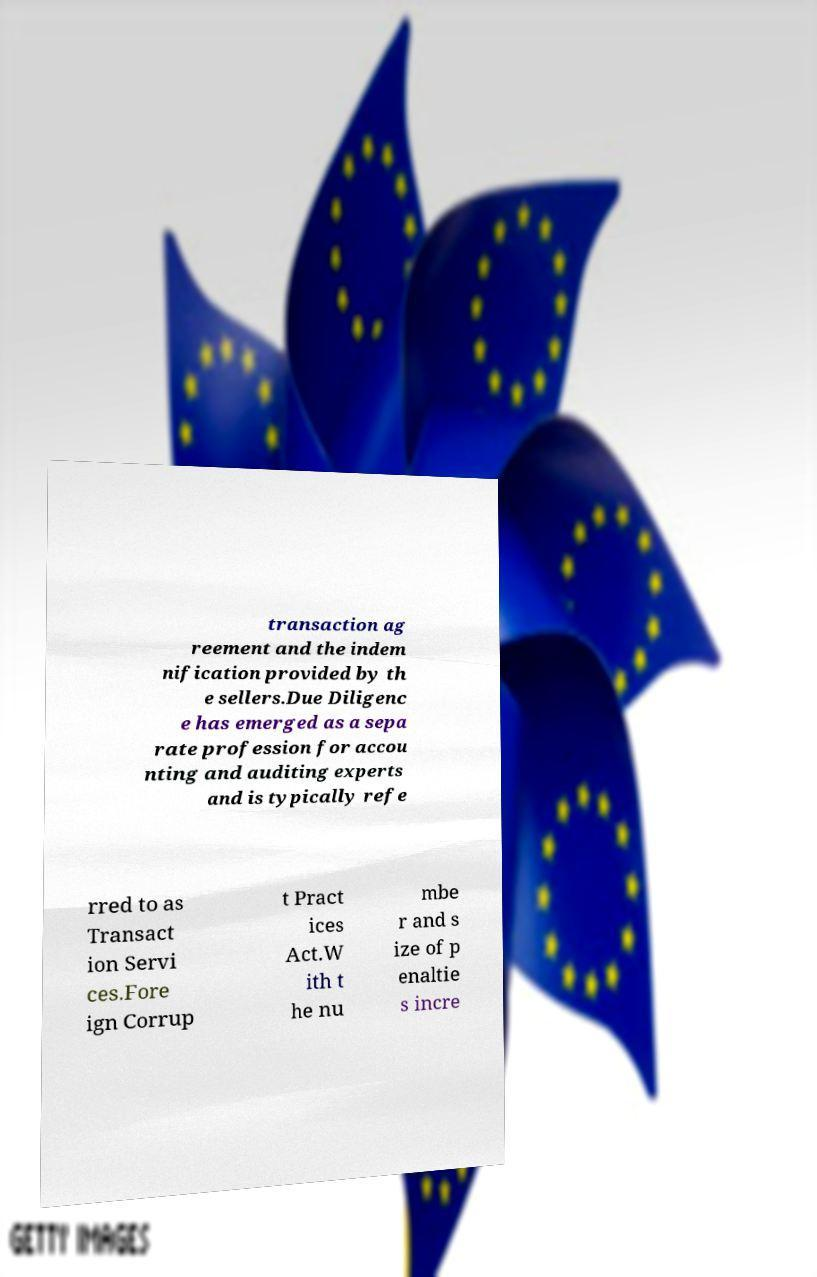For documentation purposes, I need the text within this image transcribed. Could you provide that? transaction ag reement and the indem nification provided by th e sellers.Due Diligenc e has emerged as a sepa rate profession for accou nting and auditing experts and is typically refe rred to as Transact ion Servi ces.Fore ign Corrup t Pract ices Act.W ith t he nu mbe r and s ize of p enaltie s incre 